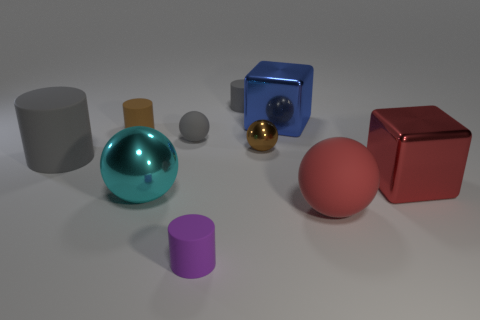Subtract all cylinders. How many objects are left? 6 Subtract all big blue things. Subtract all tiny purple blocks. How many objects are left? 9 Add 8 small purple cylinders. How many small purple cylinders are left? 9 Add 5 small matte spheres. How many small matte spheres exist? 6 Subtract 0 yellow blocks. How many objects are left? 10 